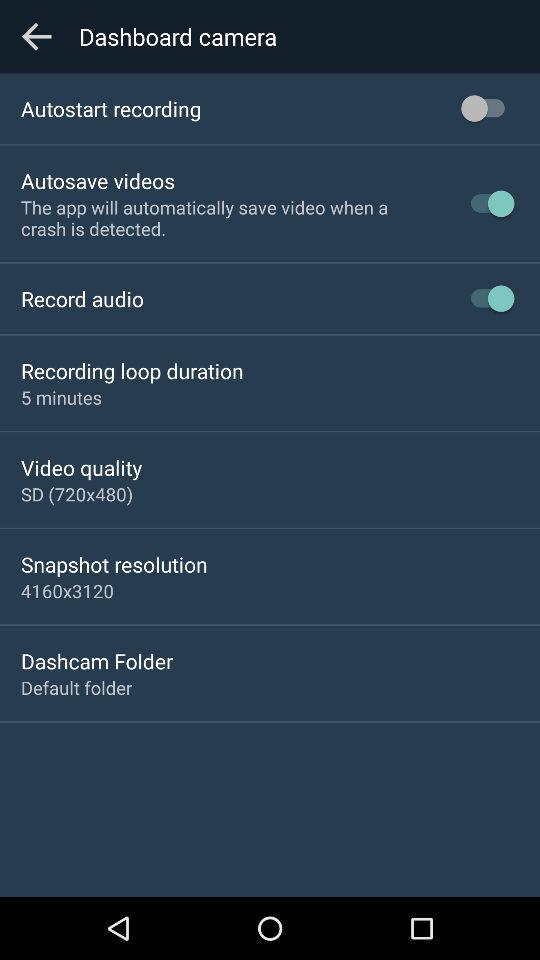What is the recording loop duration? The recording loop duration is 5 minutes. 